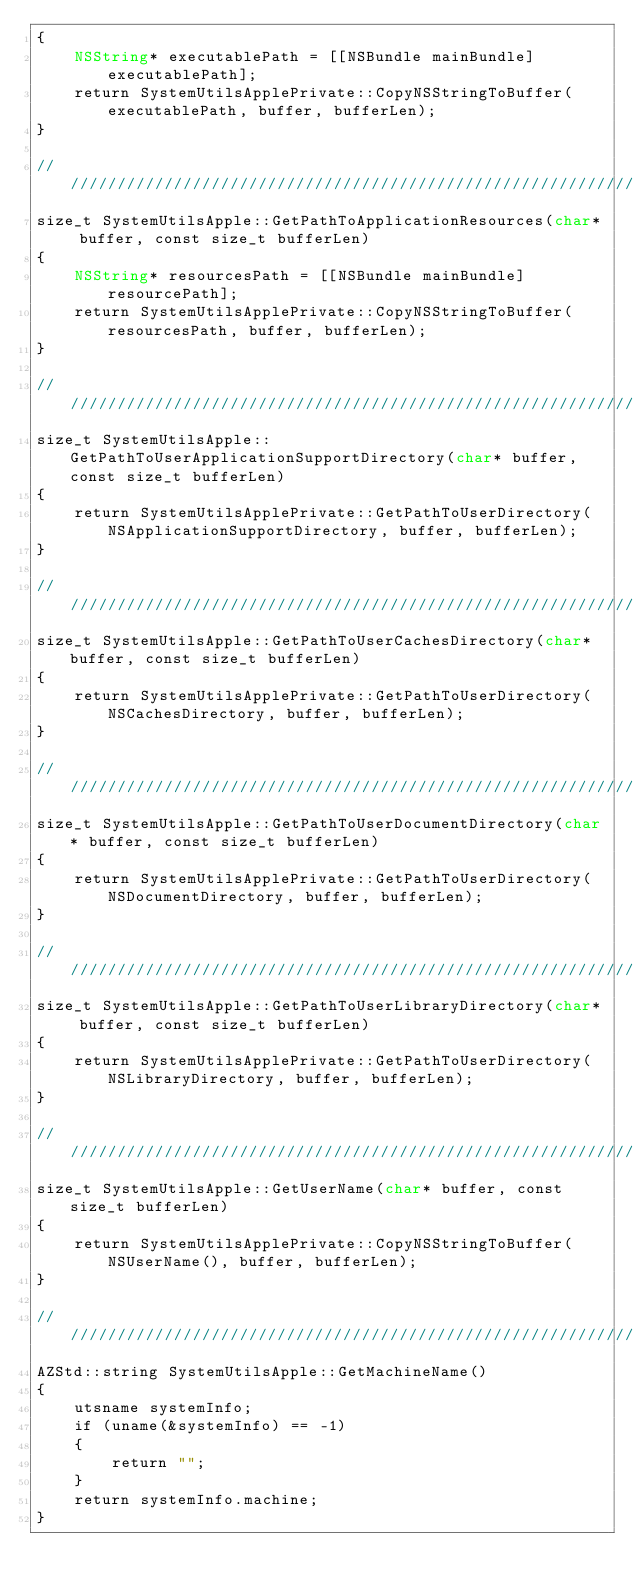<code> <loc_0><loc_0><loc_500><loc_500><_ObjectiveC_>{
    NSString* executablePath = [[NSBundle mainBundle] executablePath];
    return SystemUtilsApplePrivate::CopyNSStringToBuffer(executablePath, buffer, bufferLen);
}

////////////////////////////////////////////////////////////////////////////////////////////////////
size_t SystemUtilsApple::GetPathToApplicationResources(char* buffer, const size_t bufferLen)
{
    NSString* resourcesPath = [[NSBundle mainBundle] resourcePath];
    return SystemUtilsApplePrivate::CopyNSStringToBuffer(resourcesPath, buffer, bufferLen);
}

////////////////////////////////////////////////////////////////////////////////////////////////////
size_t SystemUtilsApple::GetPathToUserApplicationSupportDirectory(char* buffer, const size_t bufferLen)
{
    return SystemUtilsApplePrivate::GetPathToUserDirectory(NSApplicationSupportDirectory, buffer, bufferLen);
}

////////////////////////////////////////////////////////////////////////////////////////////////////
size_t SystemUtilsApple::GetPathToUserCachesDirectory(char* buffer, const size_t bufferLen)
{
    return SystemUtilsApplePrivate::GetPathToUserDirectory(NSCachesDirectory, buffer, bufferLen);
}

////////////////////////////////////////////////////////////////////////////////////////////////////
size_t SystemUtilsApple::GetPathToUserDocumentDirectory(char* buffer, const size_t bufferLen)
{
    return SystemUtilsApplePrivate::GetPathToUserDirectory(NSDocumentDirectory, buffer, bufferLen);
}

////////////////////////////////////////////////////////////////////////////////////////////////////
size_t SystemUtilsApple::GetPathToUserLibraryDirectory(char* buffer, const size_t bufferLen)
{
    return SystemUtilsApplePrivate::GetPathToUserDirectory(NSLibraryDirectory, buffer, bufferLen);
}

////////////////////////////////////////////////////////////////////////////////////////////////////
size_t SystemUtilsApple::GetUserName(char* buffer, const size_t bufferLen)
{
    return SystemUtilsApplePrivate::CopyNSStringToBuffer(NSUserName(), buffer, bufferLen);
}

////////////////////////////////////////////////////////////////////////////////////////////////////
AZStd::string SystemUtilsApple::GetMachineName() 
{
    utsname systemInfo;
    if (uname(&systemInfo) == -1)
    {
        return "";
    }
    return systemInfo.machine;
}
</code> 